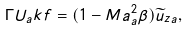<formula> <loc_0><loc_0><loc_500><loc_500>\Gamma U _ { a } k f = ( 1 - M a _ { a } ^ { 2 } \beta ) \widetilde { u } _ { z a } ,</formula> 